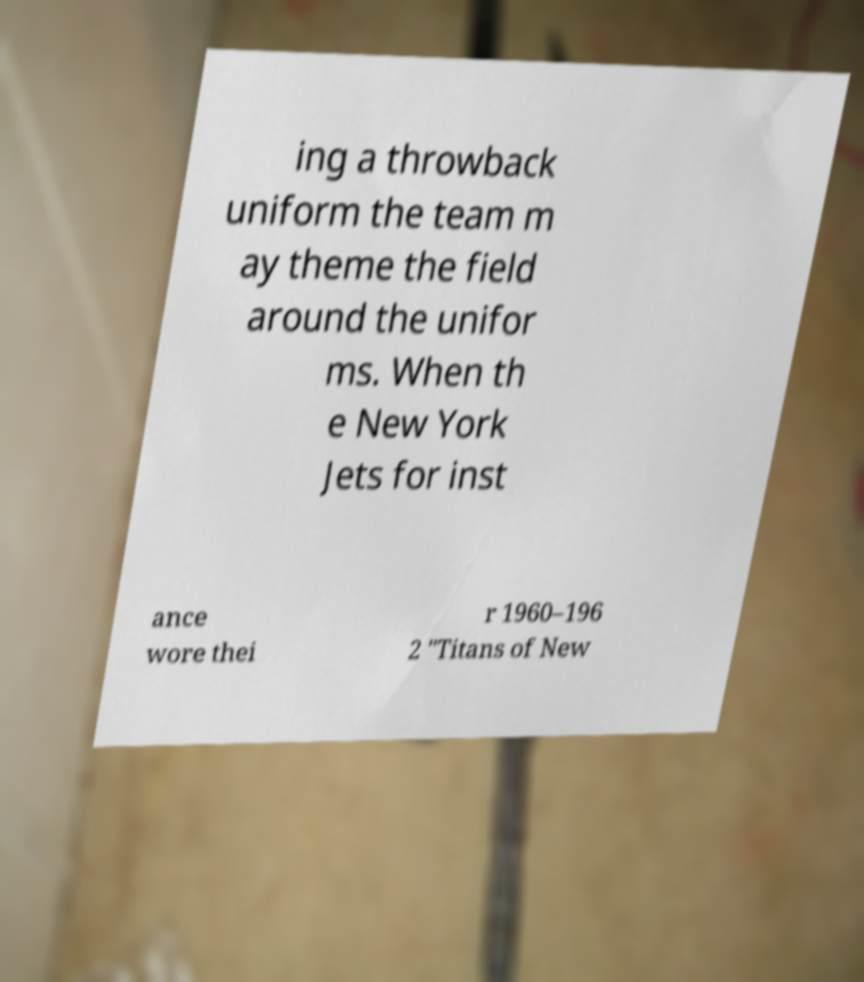I need the written content from this picture converted into text. Can you do that? ing a throwback uniform the team m ay theme the field around the unifor ms. When th e New York Jets for inst ance wore thei r 1960–196 2 "Titans of New 